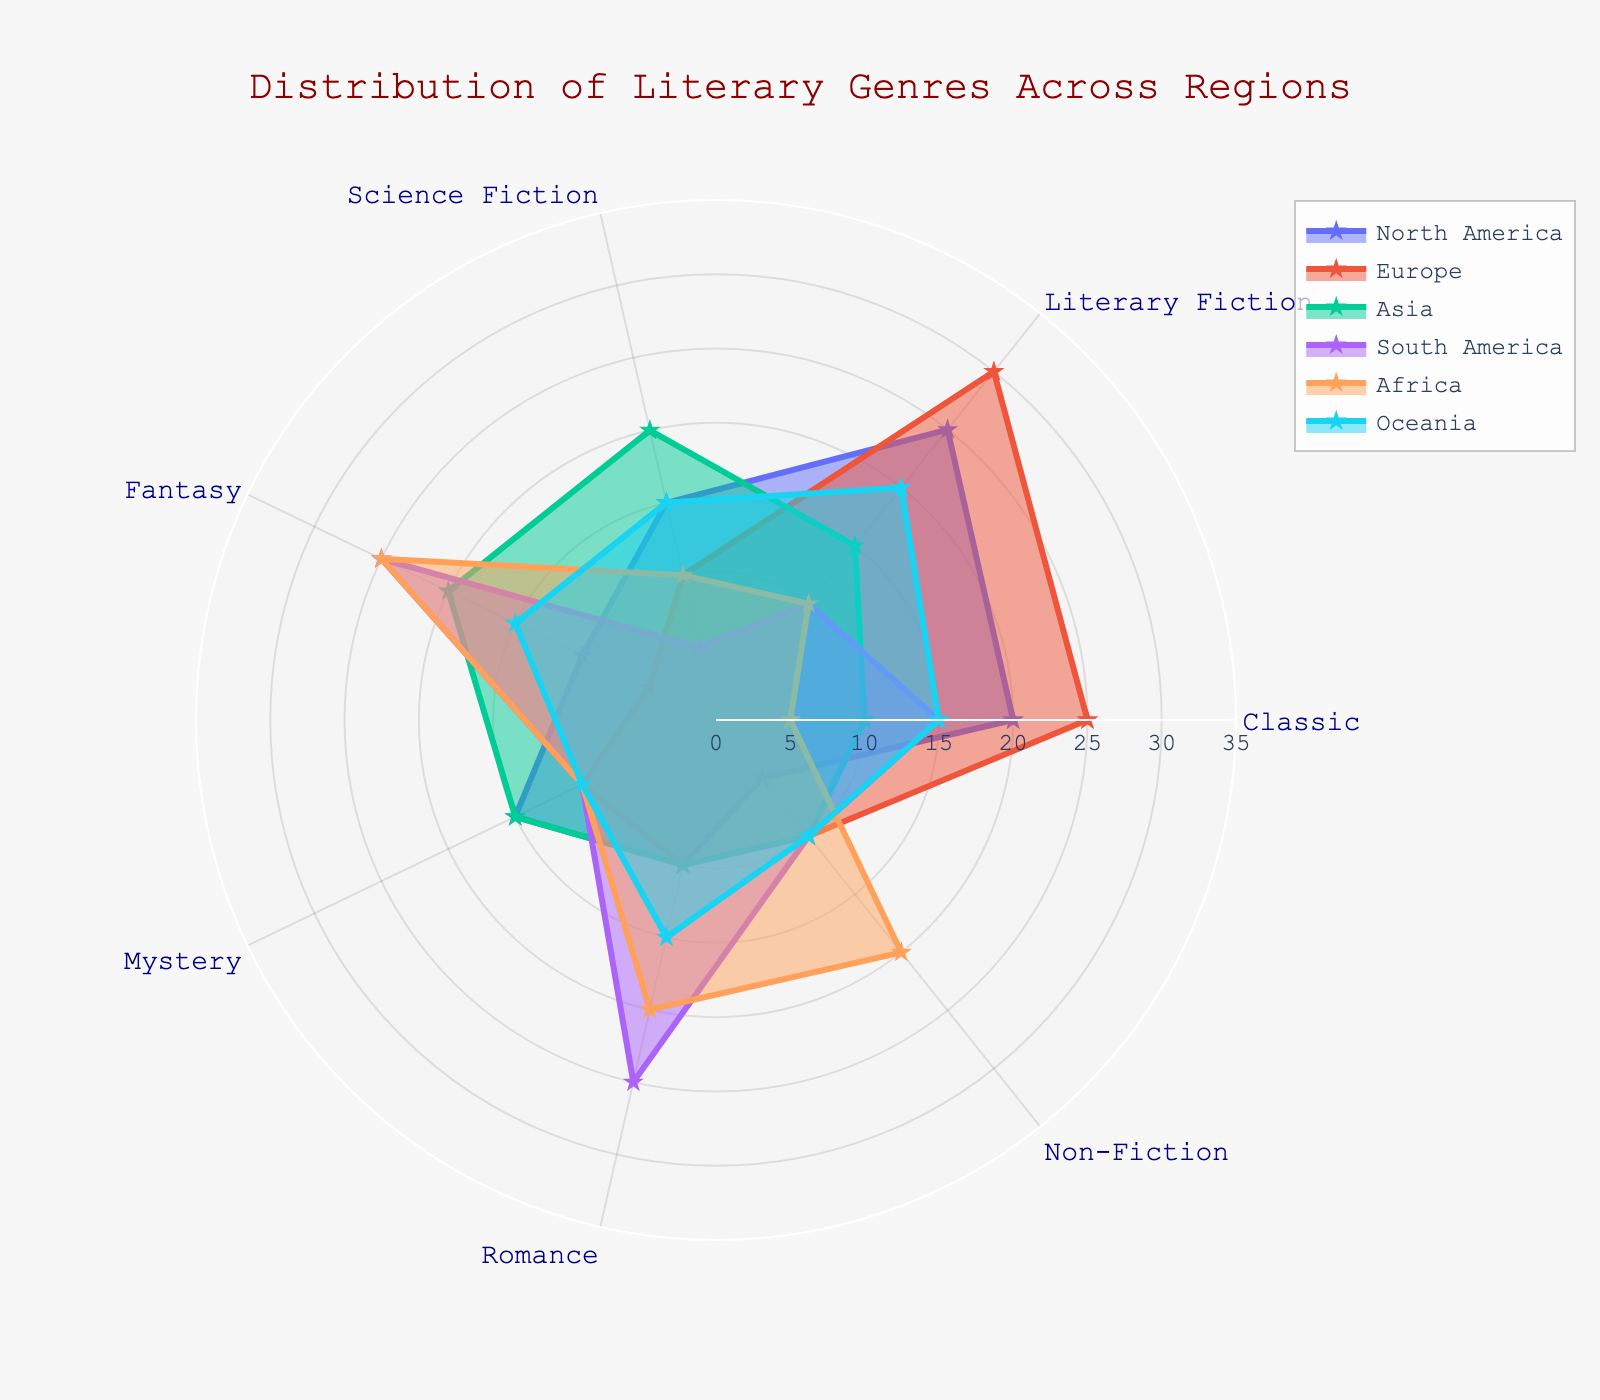Which region has the highest value in Literary Fiction? By examining the radar chart, we can see that values of Literary Fiction are plotted on one of the axes. The region with the largest radial distance for Literary Fiction is Europe.
Answer: Europe Which region has the smallest value in Classic genres? The lowest value in Classic genres corresponds to the smallest radial distance on that axis. Africa, with a value of 5, has the smallest representation in Classic genres.
Answer: Africa What is the average value of Science Fiction across all regions? Add up the values of Science Fiction for all regions: 15(North America) + 10(Europe) + 20(Asia) + 5(South America) + 10(Africa) + 15 (Oceania) = 75. Then divide by the number of regions, which is 6: 75 / 6 = 12.5
Answer: 12.5 Which genre shows a significant peak for South America, and what is its value? Check each axis on the radar chart for South America's high values. The genre with the largest peak is Fantasy, with a value of 25.
Answer: Fantasy, 25 Compare the Mystery genre representation in North America and Asia. Which region has a higher value and by how much? North America has a value of 15 and Asia has a value of 15 in Mystery. Comparing these, North America and Asia have equal values.
Answer: They have equal values Which region shows a balanced distribution (values close to each other) across all genres? By observing patterns, Oceania's values don't show wide fluctuations (Classic 15, Literary Fiction 20, Science Fiction 15, Fantasy 15, Mystery 10, Romance 15, Non-Fiction 10). Other regions have more variation in at least one category.
Answer: Oceania What is the total value for non-fiction across all regions? Add up the values of Non-Fiction for all regions: 5(North America) + 10(Europe) + 10(Asia) + 10(South America) + 20(Africa) + 10(Oceania) = 65.
Answer: 65 Which genre is more represented in Africa compared to its presence in Europe? By comparing genre by genre, Africa has a higher value than Europe in Non-Fiction (Africa 20, Europe 10).
Answer: Non-Fiction 